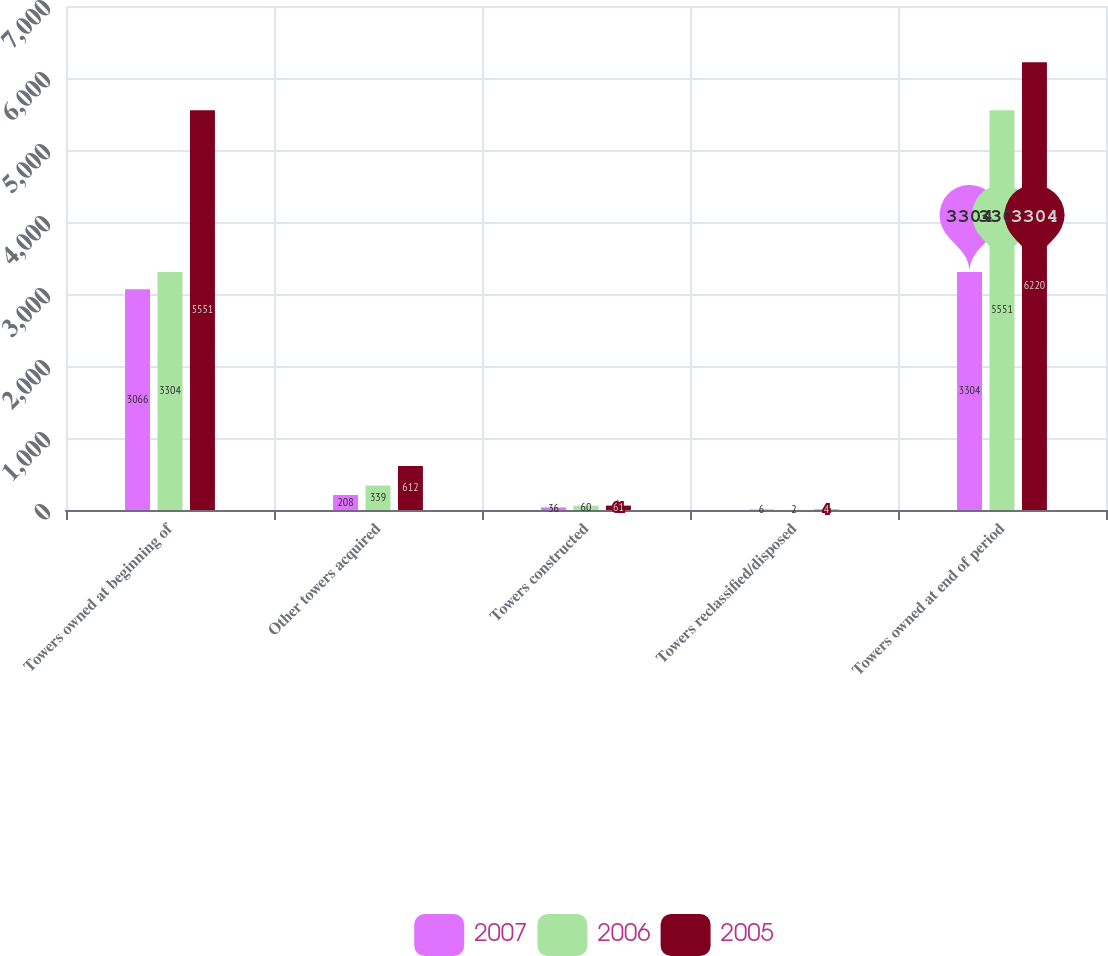Convert chart. <chart><loc_0><loc_0><loc_500><loc_500><stacked_bar_chart><ecel><fcel>Towers owned at beginning of<fcel>Other towers acquired<fcel>Towers constructed<fcel>Towers reclassified/disposed<fcel>Towers owned at end of period<nl><fcel>2007<fcel>3066<fcel>208<fcel>36<fcel>6<fcel>3304<nl><fcel>2006<fcel>3304<fcel>339<fcel>60<fcel>2<fcel>5551<nl><fcel>2005<fcel>5551<fcel>612<fcel>61<fcel>4<fcel>6220<nl></chart> 